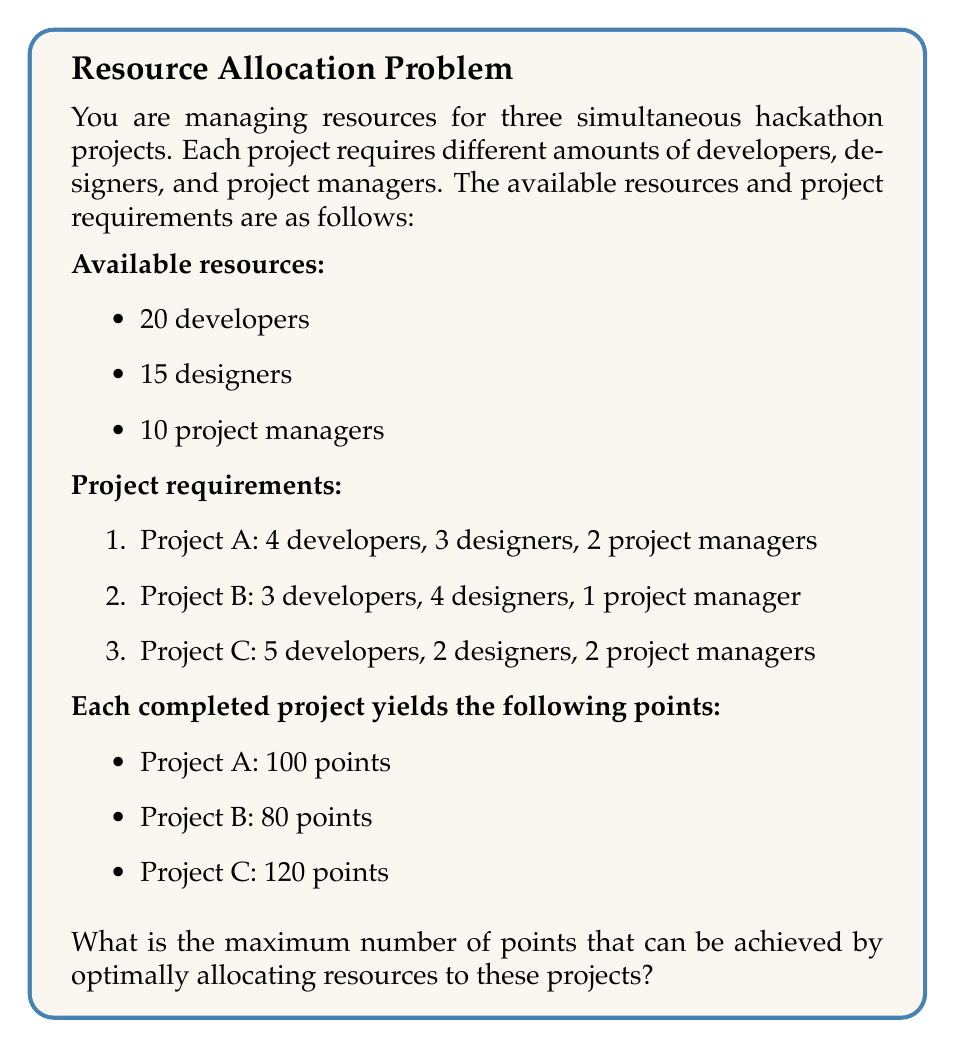What is the answer to this math problem? To solve this problem, we'll use linear programming. Let's define our variables:

$x_A$, $x_B$, and $x_C$ represent the number of times each project is completed.

Our objective function is to maximize the total points:

$$\text{Maximize } Z = 100x_A + 80x_B + 120x_C$$

Subject to the following constraints:

1. Developers: $4x_A + 3x_B + 5x_C \leq 20$
2. Designers: $3x_A + 4x_B + 2x_C \leq 15$
3. Project Managers: $2x_A + x_B + 2x_C \leq 10$
4. Non-negativity: $x_A, x_B, x_C \geq 0$

We can solve this using the simplex method or a linear programming solver. However, given the small scale of the problem, we can also use a systematic approach:

1. Start by maximizing Project C (highest points):
   We can complete 2 Project C's using 10 developers, 4 designers, and 4 project managers.
   Remaining resources: 10 developers, 11 designers, 6 project managers

2. With remaining resources, we can complete 2 Project A's:
   This uses 8 developers, 6 designers, and 4 project managers.
   Remaining resources: 2 developers, 5 designers, 2 project managers

3. Finally, we can complete 1 Project B with the remaining resources.

So, the optimal allocation is:
- 2 Project C's
- 2 Project A's
- 1 Project B

The total points achieved:
$$(2 \times 120) + (2 \times 100) + (1 \times 80) = 520 \text{ points}$$
Answer: The maximum number of points that can be achieved by optimally allocating resources is 520 points. 